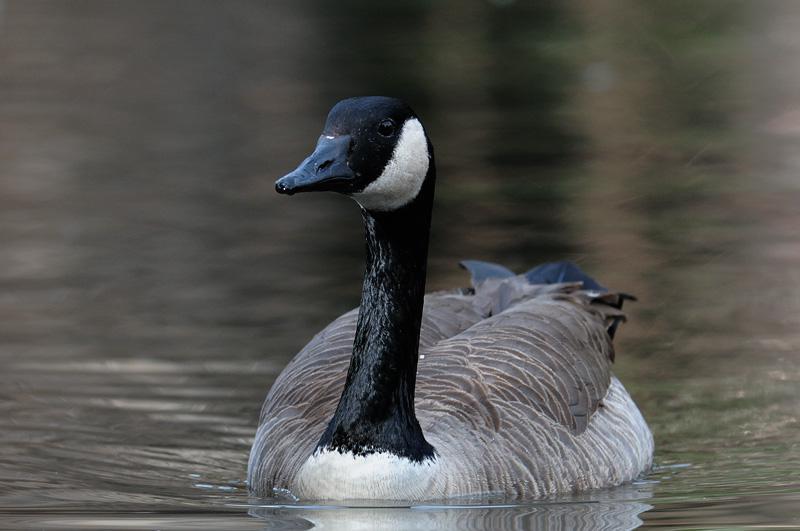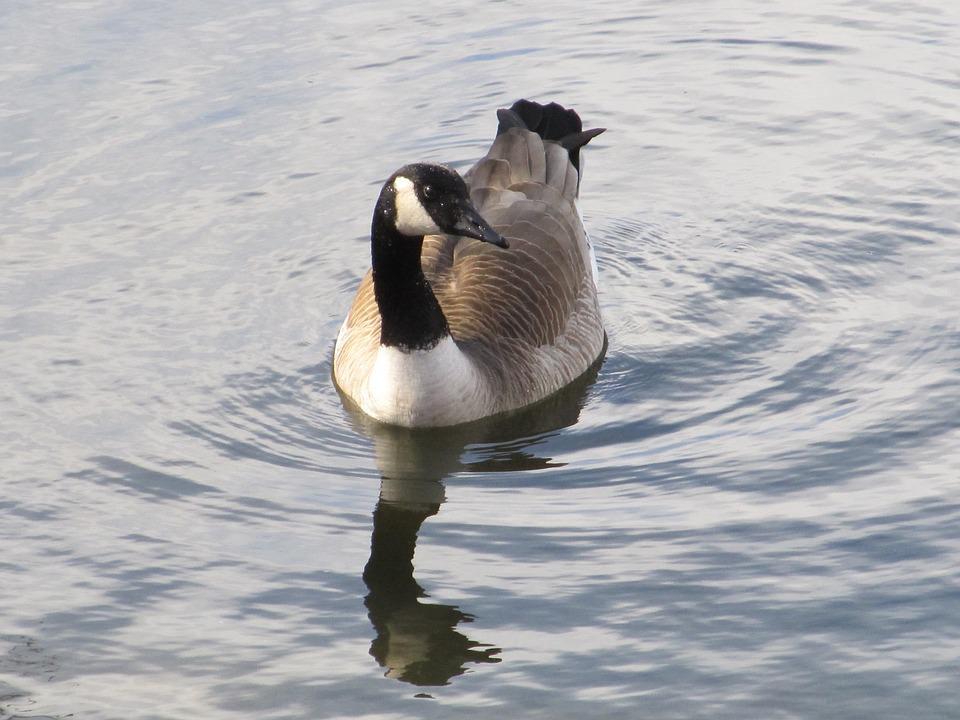The first image is the image on the left, the second image is the image on the right. Given the left and right images, does the statement "The image on the right has no more than one duck and it's body is facing right." hold true? Answer yes or no. No. The first image is the image on the left, the second image is the image on the right. Considering the images on both sides, is "There are two adult Canadian geese floating on water" valid? Answer yes or no. Yes. 